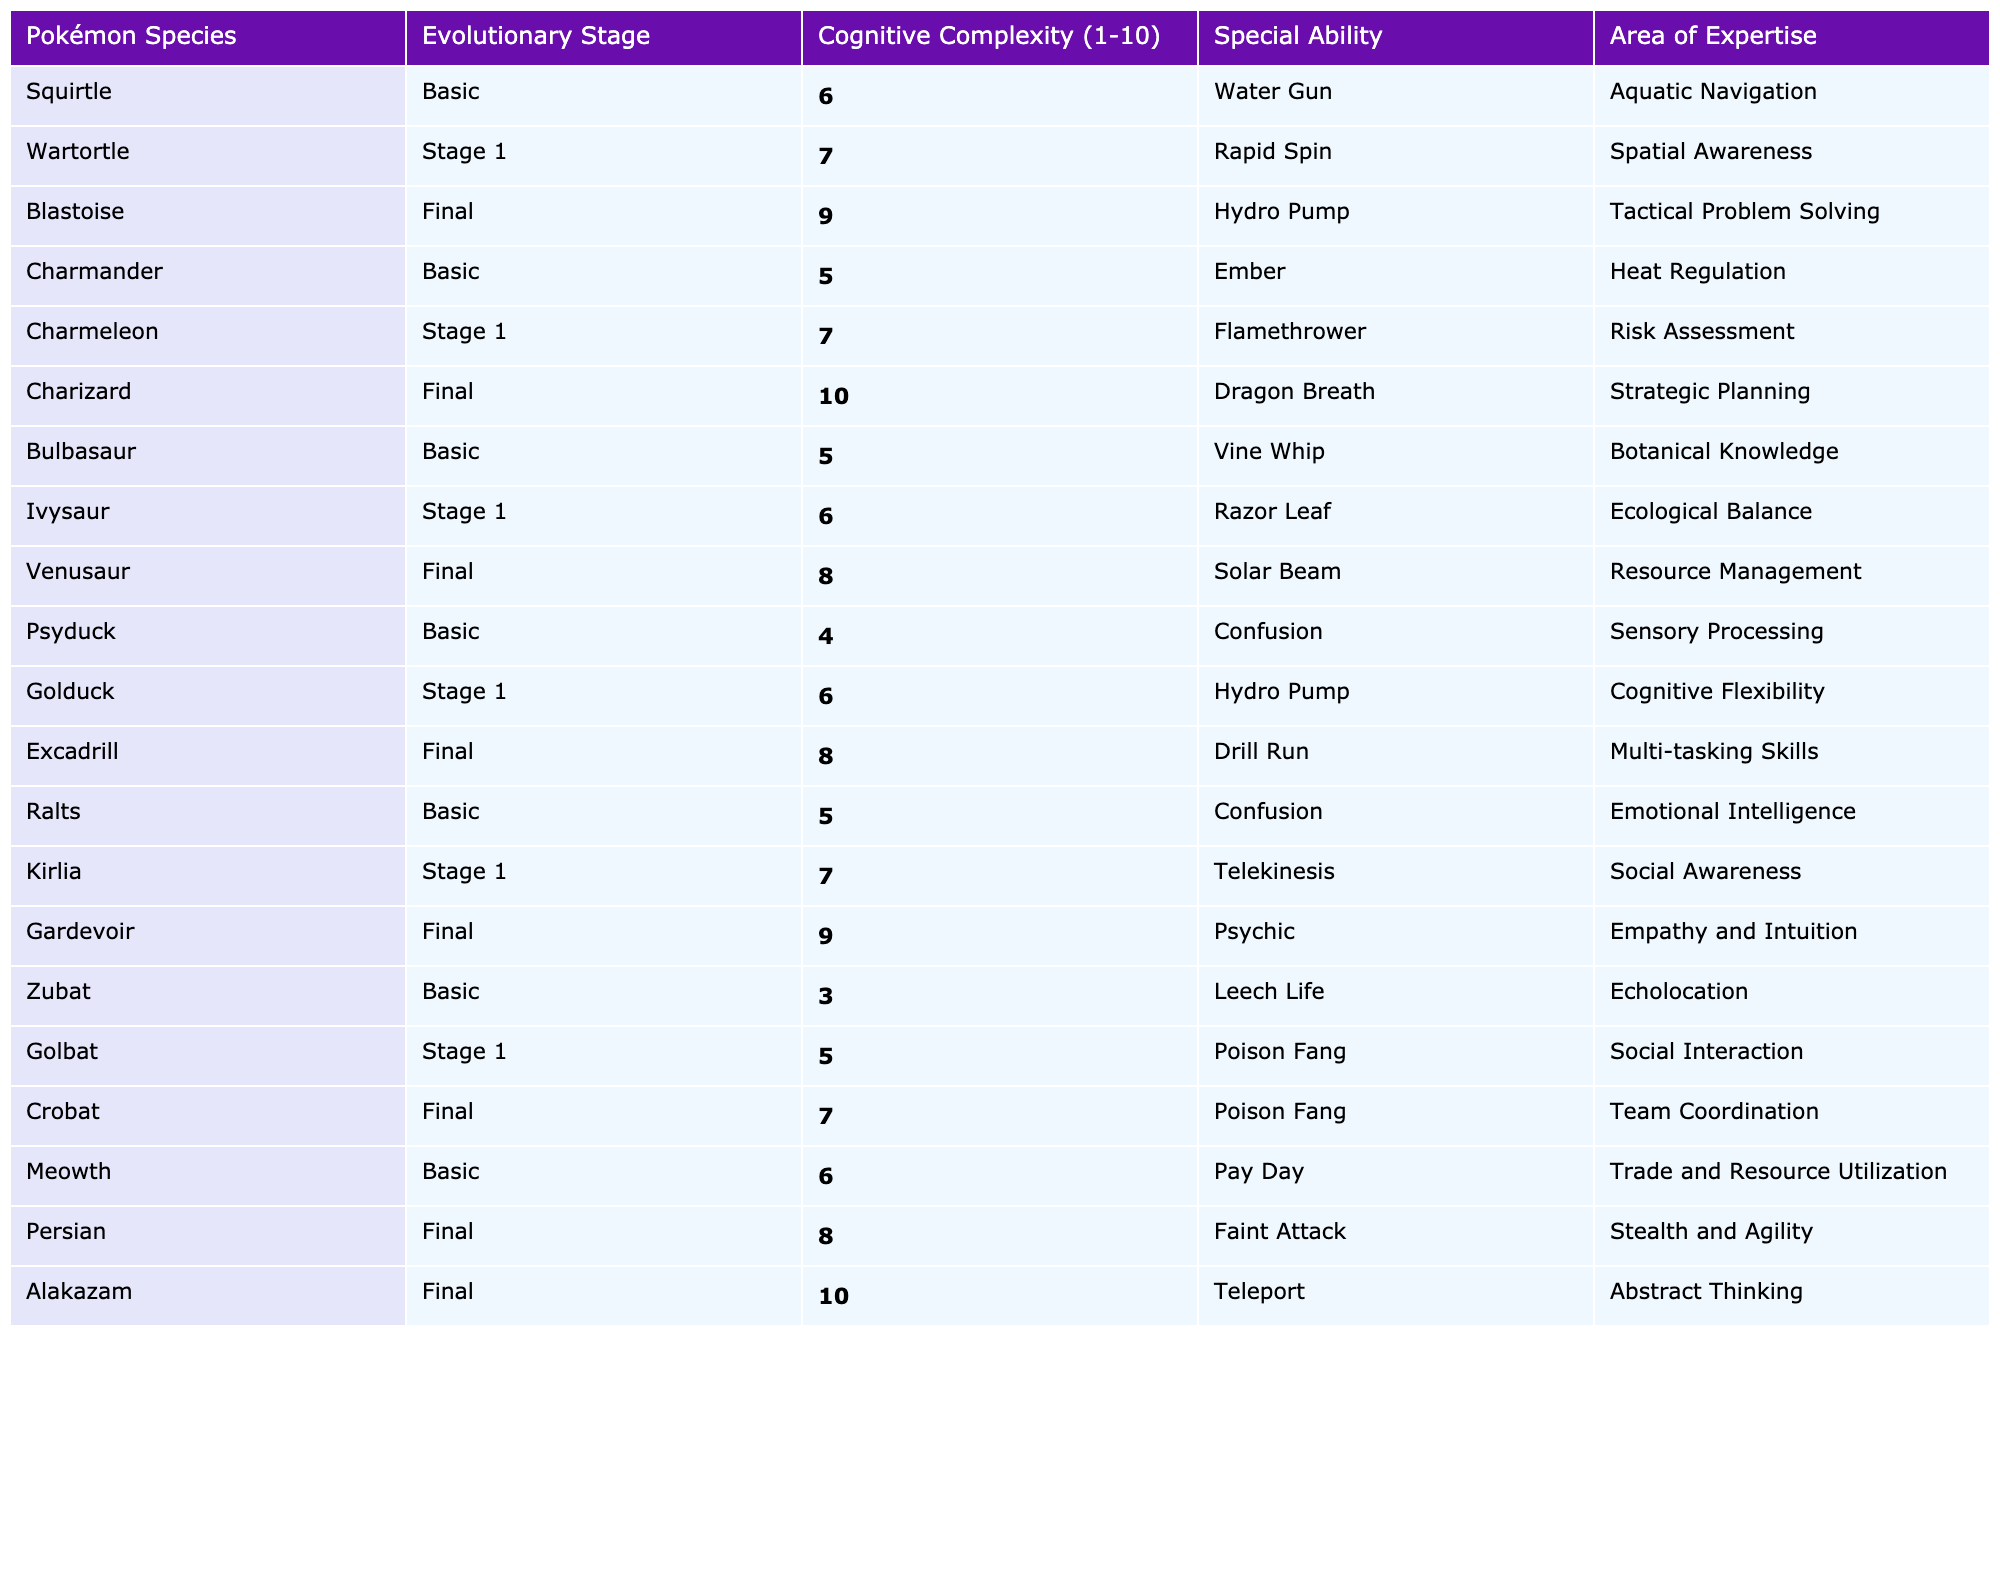What is the highest cognitive complexity rating in the table? The highest cognitive complexity rating is 10. By inspecting the "Cognitive Complexity (1-10)" column, I see that both Charizard and Alakazam are rated 10.
Answer: 10 Which Pokémon has the lowest cognitive complexity? The lowest cognitive complexity is 3, found in Zubat. I looked at the "Cognitive Complexity (1-10)" column and identified the lowest value.
Answer: 3 How many Pokémon species are at the final evolutionary stage? There are 5 Pokémon species that are in their final evolutionary stage. By counting the entries in the "Evolutionary Stage" column where the value is "Final," I find a total of 5 species.
Answer: 5 What is the cognitive complexity of the Pokémon with the special ability "Hydro Pump"? Golduck possesses the special ability "Hydro Pump" and has a cognitive complexity of 6. I searched the table for "Hydro Pump" and identified Golduck's cognitive complexity.
Answer: 6 Is "Emotional Intelligence" an area of expertise for any final stage Pokémon? No, "Emotional Intelligence" is not listed as an area of expertise for any final stage Pokémon. I checked the "Area of Expertise" column specifically for final stage entries and found it does not appear.
Answer: No Calculate the average cognitive complexity for the basic stage Pokémon. The basic stage Pokémon and their complexities are Squirtle (6), Charmander (5), Bulbasaur (5), Psyduck (4), Ralts (5), Zubat (3), and Meowth (6). Summing these values gives 34. There are 7 Pokémon, so the average is 34 divided by 7, which equals approximately 4.86.
Answer: 4.86 Which final evolution Pokémon has the special ability "Dragon Breath"? Charizard is the final evolution Pokémon with the special ability "Dragon Breath". I found "Dragon Breath" in the "Special Ability" column and noted its corresponding Pokémon species.
Answer: Charizard List the Pokémon with an area of expertise in "Strategic Planning". Charizard is the only Pokémon that has "Strategic Planning" as its area of expertise. I referred to the "Area of Expertise" column to identify the Pokémon associated with that expertise.
Answer: Charizard What is the cognitive complexity difference between Blastoise and Charmeleon? Blastoise has a cognitive complexity of 9, while Charmeleon has a cognitive complexity of 7. The difference is 9 minus 7, resulting in a difference of 2.
Answer: 2 Does any Pokémon with a basic evolutionary stage have a cognitive complexity rating of 4 or lower? Yes, Psyduck has a cognitive complexity rating of 4 in the basic stage. I examined the "Basic" section and found Psyduck’s cognitive complexity.
Answer: Yes Which Pokémon has the highest cognitive complexity among Stage 1 Pokémon? Gardevoir, with a cognitive complexity of 9, is the highest among the Stage 1 Pokémon. I analyzed the "Cognitive Complexity (1-10)" column within the "Stage 1" classifications.
Answer: Gardevoir 